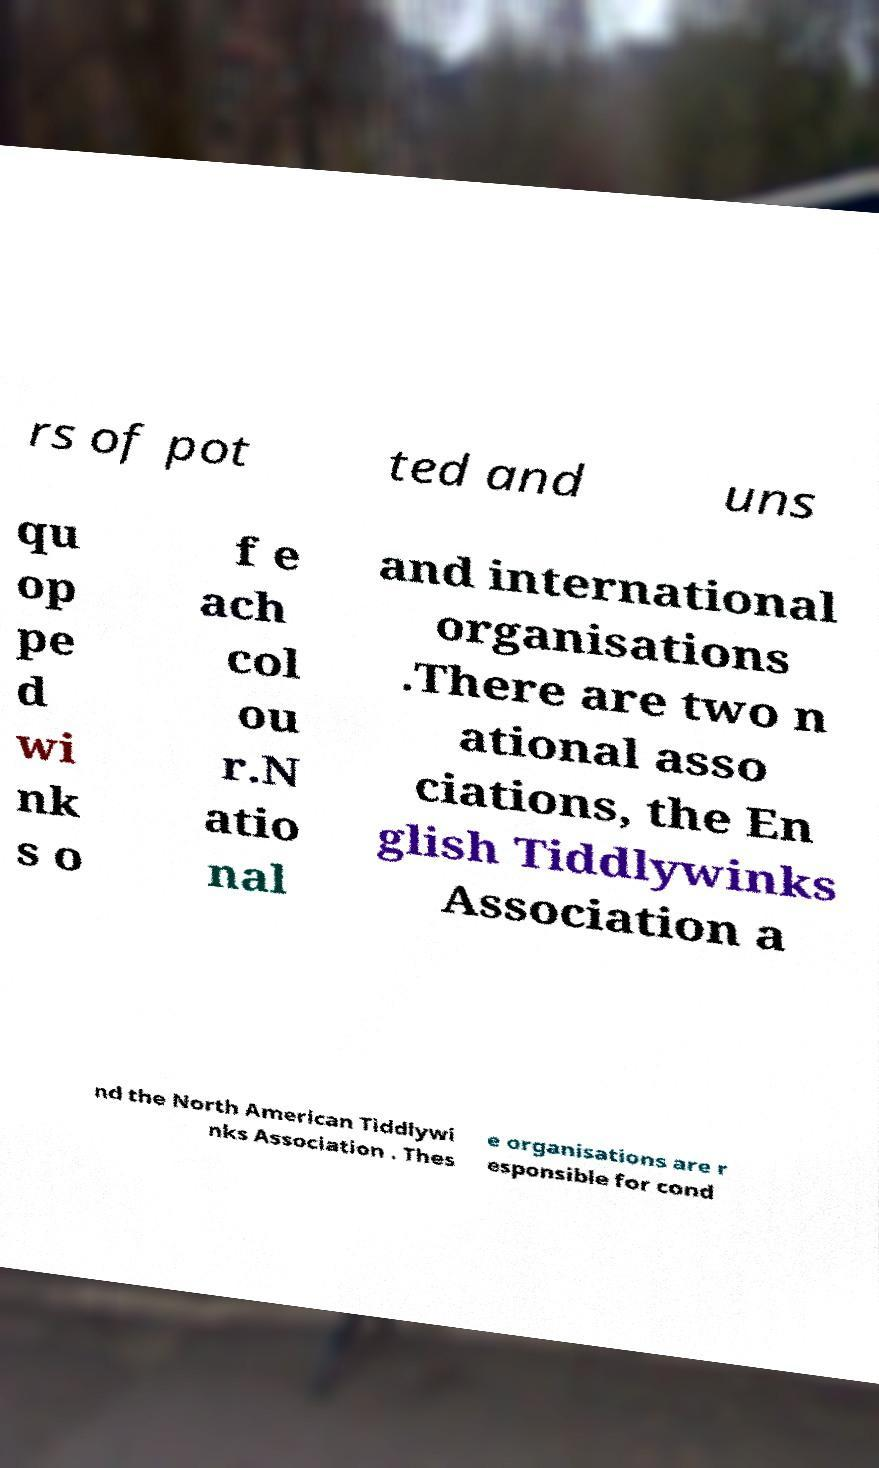There's text embedded in this image that I need extracted. Can you transcribe it verbatim? rs of pot ted and uns qu op pe d wi nk s o f e ach col ou r.N atio nal and international organisations .There are two n ational asso ciations, the En glish Tiddlywinks Association a nd the North American Tiddlywi nks Association . Thes e organisations are r esponsible for cond 